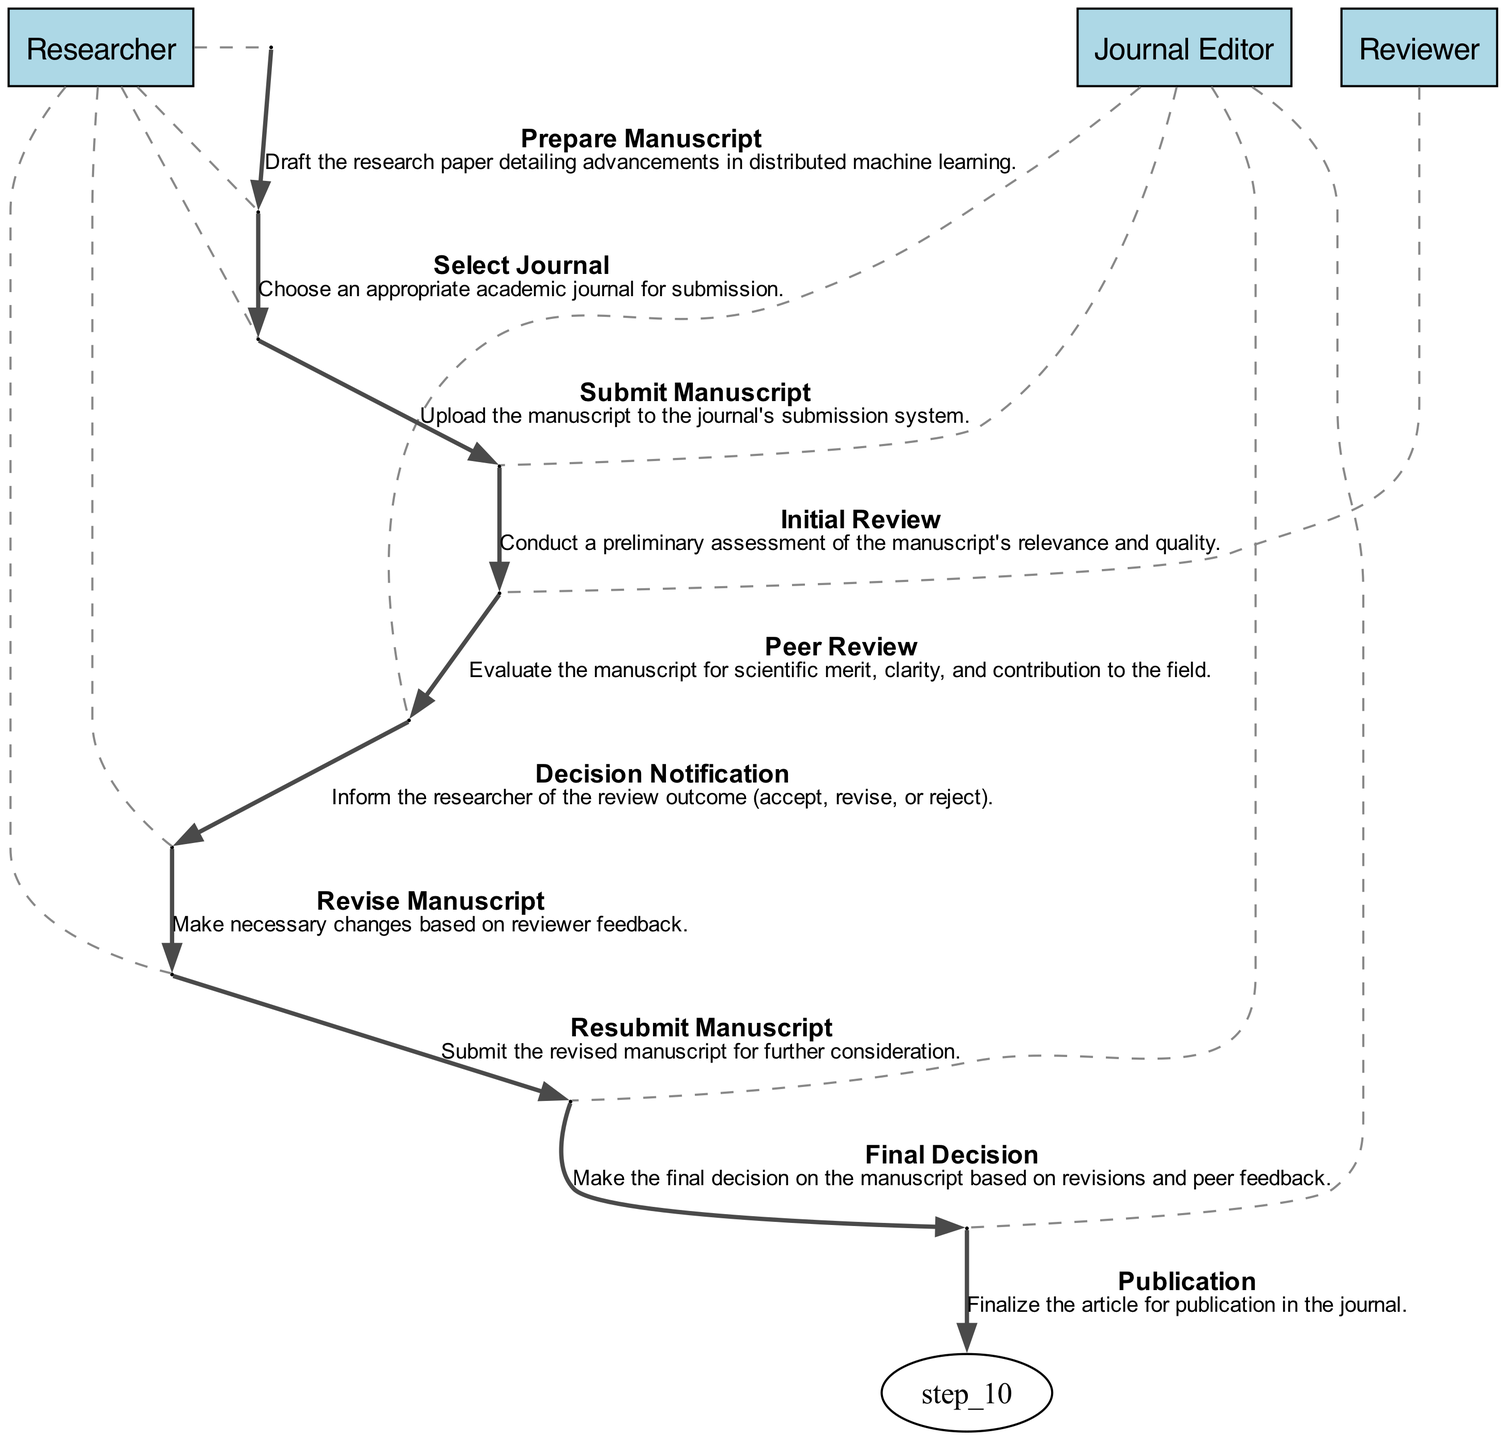What is the first action taken by the Researcher? The first action taken by the Researcher is "Prepare Manuscript," as shown at the beginning of the diagram.
Answer: Prepare Manuscript How many main actors are involved in the submission process? There are three main actors involved: Researcher, Journal Editor, and Reviewer, as identified at various stages of the diagram.
Answer: Three What action follows the "Submit Manuscript" action? Following the "Submit Manuscript" action, the next action is "Initial Review" conducted by the Journal Editor.
Answer: Initial Review What is the final action in the submission process? The final action in the submission process is "Publication," which is the last step performed by the Journal Editor.
Answer: Publication Which actor performs the "Peer Review"? The "Peer Review" action is performed by the Reviewer, as indicated in the sequence of actions in the diagram.
Answer: Reviewer What happens after the "Decision Notification"? After the "Decision Notification," the Researcher must "Revise Manuscript" based on the feedback received.
Answer: Revise Manuscript How many total actions are represented in the diagram? The diagram represents a total of ten actions, as indicated by the ten elements listed in the data.
Answer: Ten Which two actions are performed by the Researcher? The two actions performed by the Researcher are "Revise Manuscript" and "Resubmit Manuscript," which follow the review process.
Answer: Revise Manuscript and Resubmit Manuscript What is the purpose of the "Initial Review" by the Journal Editor? The purpose of the "Initial Review" is to conduct a preliminary assessment of the manuscript's relevance and quality, as stated in the description for that action.
Answer: Preliminary assessment What is the relationship between "Revise Manuscript" and "Resubmit Manuscript"? The relationship is sequential; "Revise Manuscript" must occur before "Resubmit Manuscript," signifying a required action based on feedback.
Answer: Sequential 